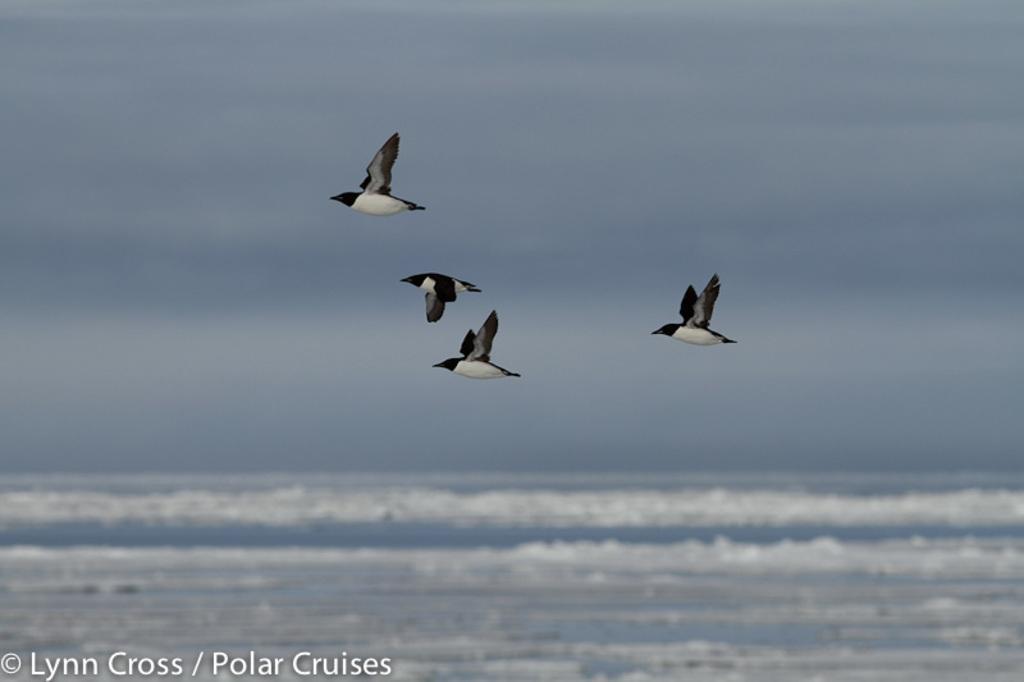In one or two sentences, can you explain what this image depicts? In this picture we can see four birds flying in the sky with clouds and in the background we can see water. 